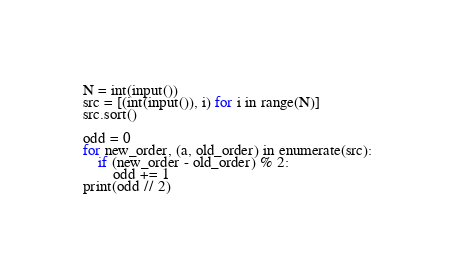<code> <loc_0><loc_0><loc_500><loc_500><_Python_>N = int(input())
src = [(int(input()), i) for i in range(N)]
src.sort()

odd = 0
for new_order, (a, old_order) in enumerate(src):
    if (new_order - old_order) % 2:
        odd += 1
print(odd // 2)
</code> 